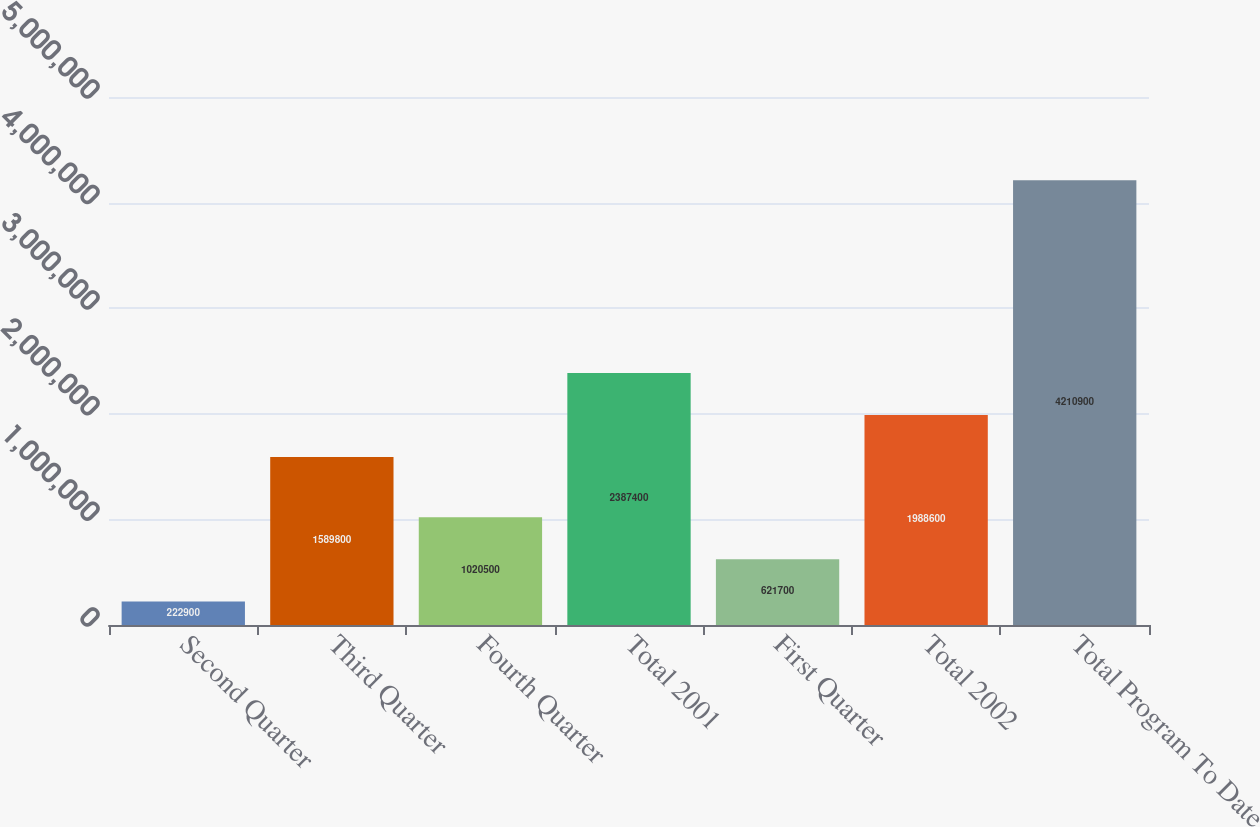Convert chart. <chart><loc_0><loc_0><loc_500><loc_500><bar_chart><fcel>Second Quarter<fcel>Third Quarter<fcel>Fourth Quarter<fcel>Total 2001<fcel>First Quarter<fcel>Total 2002<fcel>Total Program To Date<nl><fcel>222900<fcel>1.5898e+06<fcel>1.0205e+06<fcel>2.3874e+06<fcel>621700<fcel>1.9886e+06<fcel>4.2109e+06<nl></chart> 